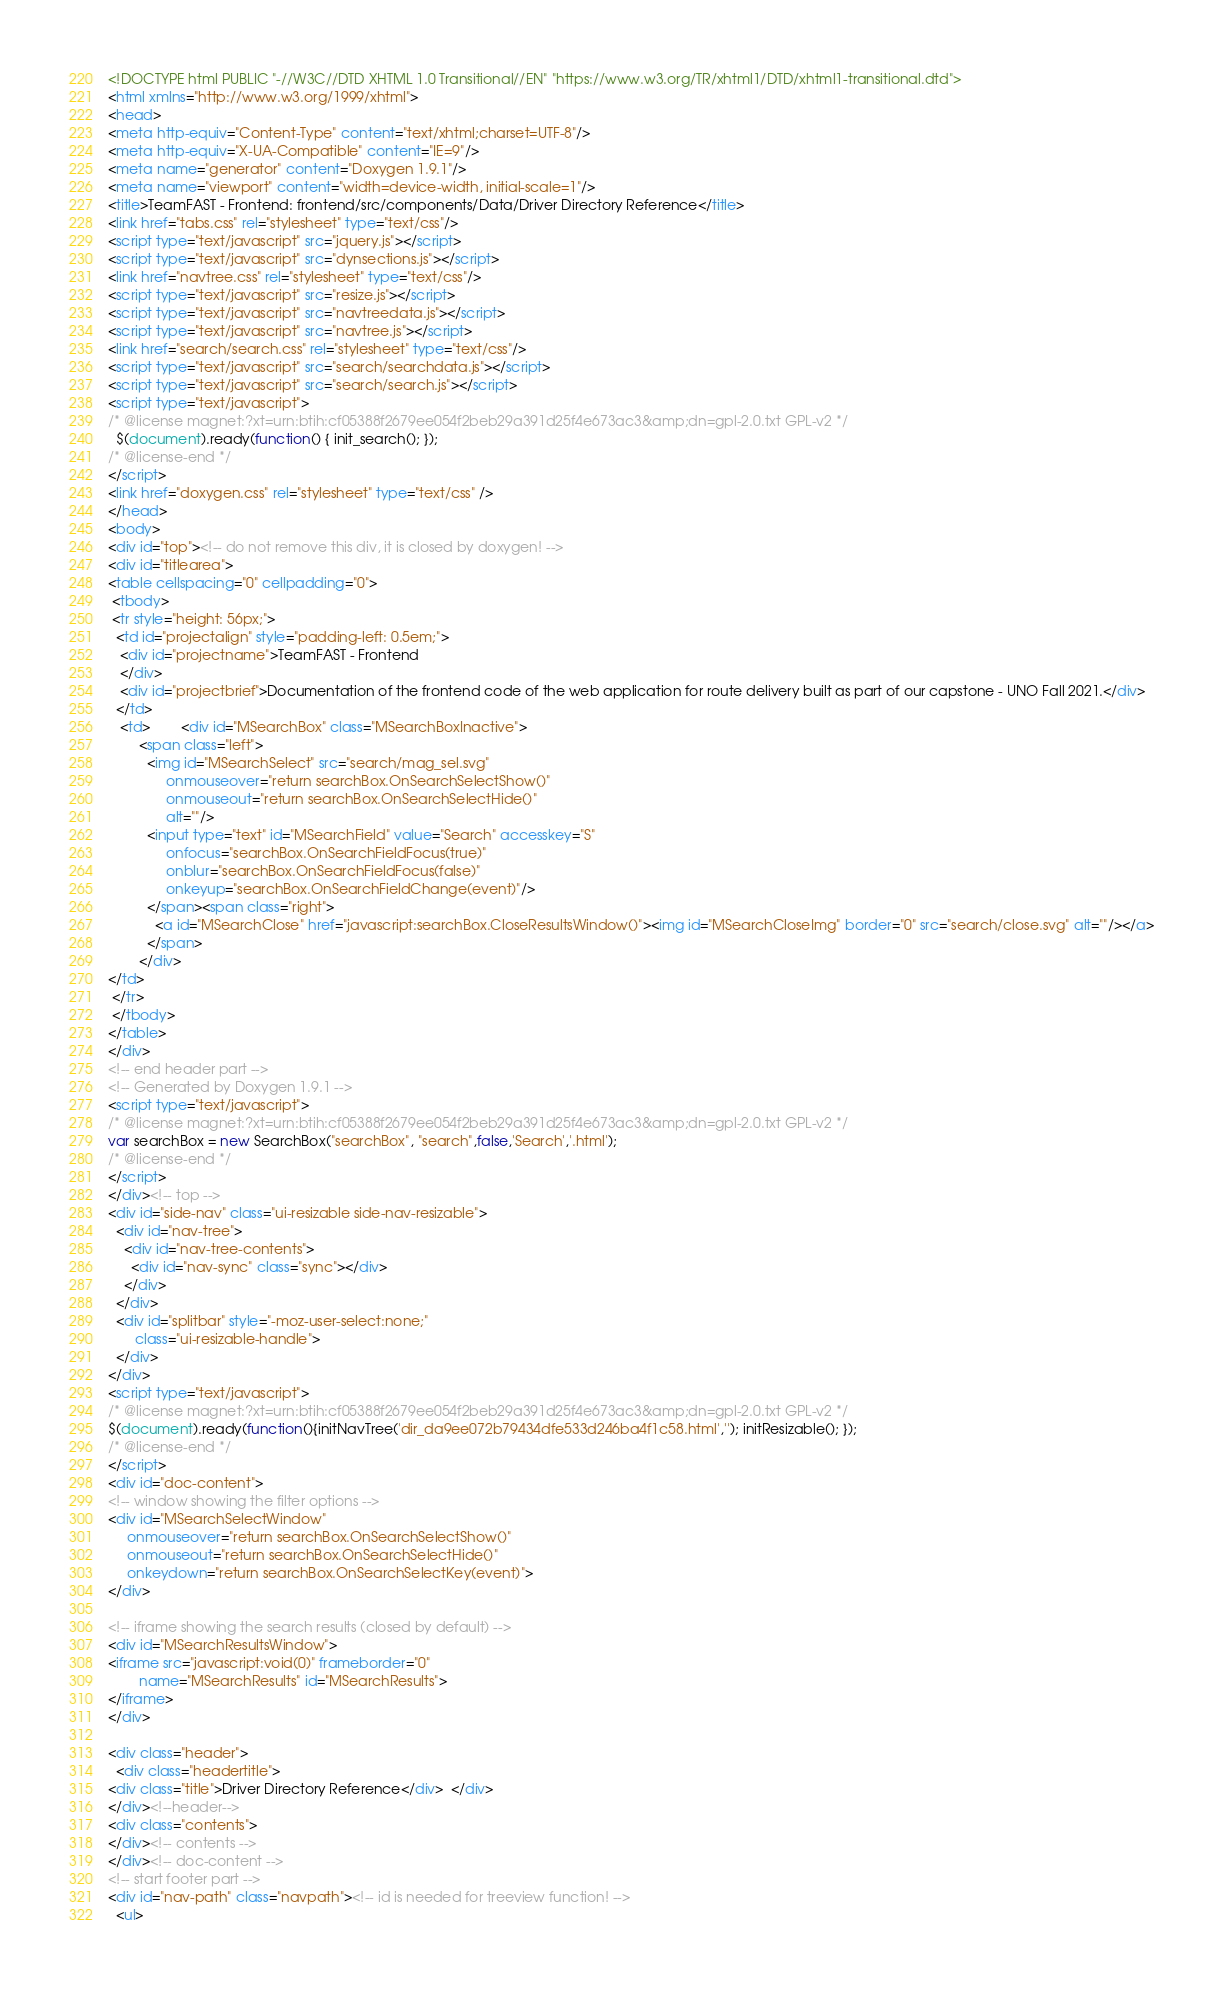Convert code to text. <code><loc_0><loc_0><loc_500><loc_500><_HTML_><!DOCTYPE html PUBLIC "-//W3C//DTD XHTML 1.0 Transitional//EN" "https://www.w3.org/TR/xhtml1/DTD/xhtml1-transitional.dtd">
<html xmlns="http://www.w3.org/1999/xhtml">
<head>
<meta http-equiv="Content-Type" content="text/xhtml;charset=UTF-8"/>
<meta http-equiv="X-UA-Compatible" content="IE=9"/>
<meta name="generator" content="Doxygen 1.9.1"/>
<meta name="viewport" content="width=device-width, initial-scale=1"/>
<title>TeamFAST - Frontend: frontend/src/components/Data/Driver Directory Reference</title>
<link href="tabs.css" rel="stylesheet" type="text/css"/>
<script type="text/javascript" src="jquery.js"></script>
<script type="text/javascript" src="dynsections.js"></script>
<link href="navtree.css" rel="stylesheet" type="text/css"/>
<script type="text/javascript" src="resize.js"></script>
<script type="text/javascript" src="navtreedata.js"></script>
<script type="text/javascript" src="navtree.js"></script>
<link href="search/search.css" rel="stylesheet" type="text/css"/>
<script type="text/javascript" src="search/searchdata.js"></script>
<script type="text/javascript" src="search/search.js"></script>
<script type="text/javascript">
/* @license magnet:?xt=urn:btih:cf05388f2679ee054f2beb29a391d25f4e673ac3&amp;dn=gpl-2.0.txt GPL-v2 */
  $(document).ready(function() { init_search(); });
/* @license-end */
</script>
<link href="doxygen.css" rel="stylesheet" type="text/css" />
</head>
<body>
<div id="top"><!-- do not remove this div, it is closed by doxygen! -->
<div id="titlearea">
<table cellspacing="0" cellpadding="0">
 <tbody>
 <tr style="height: 56px;">
  <td id="projectalign" style="padding-left: 0.5em;">
   <div id="projectname">TeamFAST - Frontend
   </div>
   <div id="projectbrief">Documentation of the frontend code of the web application for route delivery built as part of our capstone - UNO Fall 2021.</div>
  </td>
   <td>        <div id="MSearchBox" class="MSearchBoxInactive">
        <span class="left">
          <img id="MSearchSelect" src="search/mag_sel.svg"
               onmouseover="return searchBox.OnSearchSelectShow()"
               onmouseout="return searchBox.OnSearchSelectHide()"
               alt=""/>
          <input type="text" id="MSearchField" value="Search" accesskey="S"
               onfocus="searchBox.OnSearchFieldFocus(true)" 
               onblur="searchBox.OnSearchFieldFocus(false)" 
               onkeyup="searchBox.OnSearchFieldChange(event)"/>
          </span><span class="right">
            <a id="MSearchClose" href="javascript:searchBox.CloseResultsWindow()"><img id="MSearchCloseImg" border="0" src="search/close.svg" alt=""/></a>
          </span>
        </div>
</td>
 </tr>
 </tbody>
</table>
</div>
<!-- end header part -->
<!-- Generated by Doxygen 1.9.1 -->
<script type="text/javascript">
/* @license magnet:?xt=urn:btih:cf05388f2679ee054f2beb29a391d25f4e673ac3&amp;dn=gpl-2.0.txt GPL-v2 */
var searchBox = new SearchBox("searchBox", "search",false,'Search','.html');
/* @license-end */
</script>
</div><!-- top -->
<div id="side-nav" class="ui-resizable side-nav-resizable">
  <div id="nav-tree">
    <div id="nav-tree-contents">
      <div id="nav-sync" class="sync"></div>
    </div>
  </div>
  <div id="splitbar" style="-moz-user-select:none;" 
       class="ui-resizable-handle">
  </div>
</div>
<script type="text/javascript">
/* @license magnet:?xt=urn:btih:cf05388f2679ee054f2beb29a391d25f4e673ac3&amp;dn=gpl-2.0.txt GPL-v2 */
$(document).ready(function(){initNavTree('dir_da9ee072b79434dfe533d246ba4f1c58.html',''); initResizable(); });
/* @license-end */
</script>
<div id="doc-content">
<!-- window showing the filter options -->
<div id="MSearchSelectWindow"
     onmouseover="return searchBox.OnSearchSelectShow()"
     onmouseout="return searchBox.OnSearchSelectHide()"
     onkeydown="return searchBox.OnSearchSelectKey(event)">
</div>

<!-- iframe showing the search results (closed by default) -->
<div id="MSearchResultsWindow">
<iframe src="javascript:void(0)" frameborder="0" 
        name="MSearchResults" id="MSearchResults">
</iframe>
</div>

<div class="header">
  <div class="headertitle">
<div class="title">Driver Directory Reference</div>  </div>
</div><!--header-->
<div class="contents">
</div><!-- contents -->
</div><!-- doc-content -->
<!-- start footer part -->
<div id="nav-path" class="navpath"><!-- id is needed for treeview function! -->
  <ul></code> 